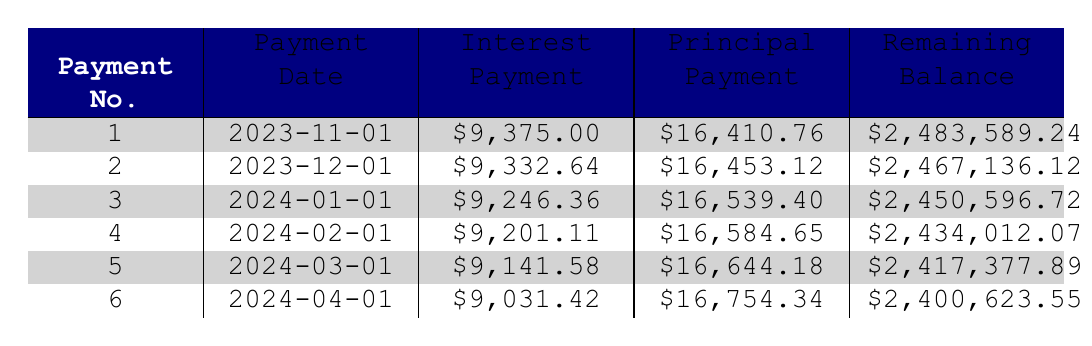What is the loan amount for the Submarine Navigation System? The loan amount is specified in the loan details section and directly corresponds to the first row in the amortization table as part of the loan description.
Answer: 2,500,000 What is the interest payment for the first payment? The interest payment for the first payment is explicitly stated in the first row of the table.
Answer: 9,375.00 How much did the remaining balance decrease after the first payment? The remaining balance before the first payment was 2,500,000, and after the first payment it is 2,483,589.24. The decrease can be calculated as 2,500,000 - 2,483,589.24, yielding a decrease of 16,410.76.
Answer: 16,410.76 What is the average principal payment of the first five payments? To find the average, sum the principal payments from the first five entries (16,410.76 + 16,453.12 + 16,539.40 + 16,584.65 + 16,644.18 = 82,632.11) and divide by 5, resulting in 82,632.11 / 5 = 16,526.42.
Answer: 16,526.42 Did the interest payment increase or decrease from the first to the second payment? To determine this, we compare the first payment's interest (9,375.00) to the second's (9,332.64). Since 9,332.64 is less than 9,375.00, the difference is negative, indicating a decrease.
Answer: Decrease In which month is the second payment due? The second payment date is clearly listed in the second row of the table, which specifies that the payment is due on 2023-12-01.
Answer: December 2023 What is the total interest paid after the first three payments? To find this, add the interest payments from the first three payments (9,375.00 + 9,332.64 + 9,246.36 = 27,954.00) to get the total interest paid.
Answer: 27,954.00 What is the remaining balance after the fourth payment? The remaining balance is directly shown in the fourth row of the amortization table, which states that the balance after the fourth payment is 2,434,012.07.
Answer: 2,434,012.07 How many months are there until the last payment is due? The loan term is 10 years, so there are 120 months in total. The first payment starts on 2023-11-01, and the last payment would be 10 years later, on 2023-10-01, thus there are 120 months or 119 more payments remaining from the first one.
Answer: 119 months 